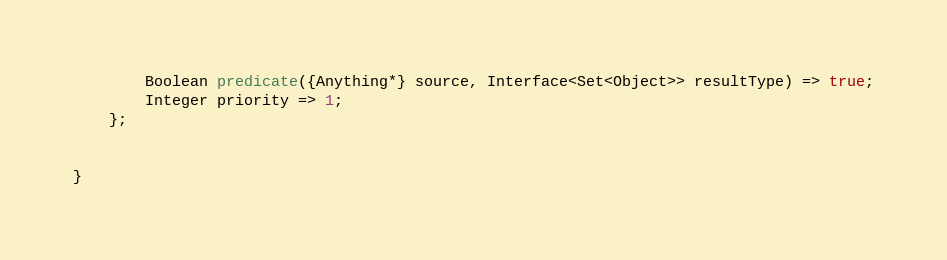Convert code to text. <code><loc_0><loc_0><loc_500><loc_500><_Ceylon_>		Boolean predicate({Anything*} source, Interface<Set<Object>> resultType) => true;
		Integer priority => 1;
	};

	
}

</code> 